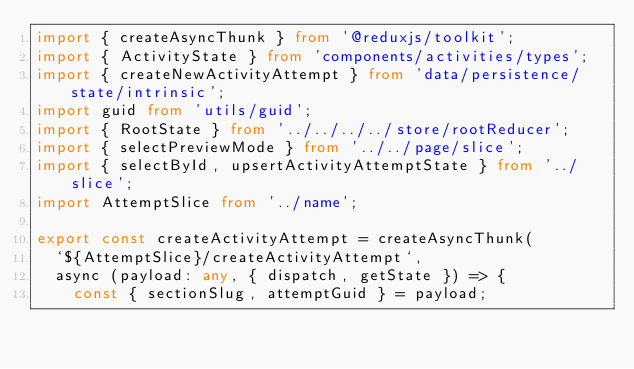Convert code to text. <code><loc_0><loc_0><loc_500><loc_500><_TypeScript_>import { createAsyncThunk } from '@reduxjs/toolkit';
import { ActivityState } from 'components/activities/types';
import { createNewActivityAttempt } from 'data/persistence/state/intrinsic';
import guid from 'utils/guid';
import { RootState } from '../../../../store/rootReducer';
import { selectPreviewMode } from '../../page/slice';
import { selectById, upsertActivityAttemptState } from '../slice';
import AttemptSlice from '../name';

export const createActivityAttempt = createAsyncThunk(
  `${AttemptSlice}/createActivityAttempt`,
  async (payload: any, { dispatch, getState }) => {
    const { sectionSlug, attemptGuid } = payload;</code> 